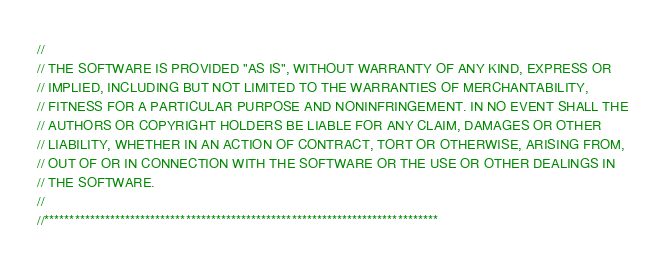Convert code to text. <code><loc_0><loc_0><loc_500><loc_500><_ObjectiveC_>//
// THE SOFTWARE IS PROVIDED "AS IS", WITHOUT WARRANTY OF ANY KIND, EXPRESS OR
// IMPLIED, INCLUDING BUT NOT LIMITED TO THE WARRANTIES OF MERCHANTABILITY,
// FITNESS FOR A PARTICULAR PURPOSE AND NONINFRINGEMENT. IN NO EVENT SHALL THE
// AUTHORS OR COPYRIGHT HOLDERS BE LIABLE FOR ANY CLAIM, DAMAGES OR OTHER
// LIABILITY, WHETHER IN AN ACTION OF CONTRACT, TORT OR OTHERWISE, ARISING FROM,
// OUT OF OR IN CONNECTION WITH THE SOFTWARE OR THE USE OR OTHER DEALINGS IN
// THE SOFTWARE.
//
//******************************************************************************
</code> 